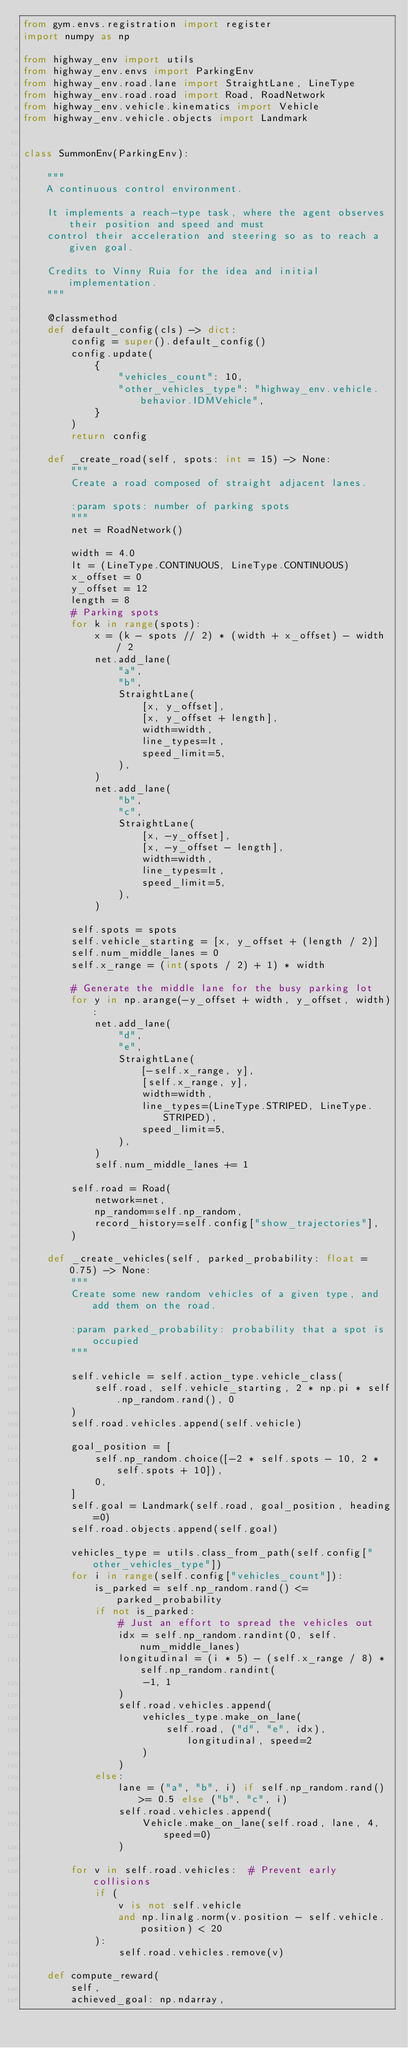Convert code to text. <code><loc_0><loc_0><loc_500><loc_500><_Python_>from gym.envs.registration import register
import numpy as np

from highway_env import utils
from highway_env.envs import ParkingEnv
from highway_env.road.lane import StraightLane, LineType
from highway_env.road.road import Road, RoadNetwork
from highway_env.vehicle.kinematics import Vehicle
from highway_env.vehicle.objects import Landmark


class SummonEnv(ParkingEnv):

    """
    A continuous control environment.

    It implements a reach-type task, where the agent observes their position and speed and must
    control their acceleration and steering so as to reach a given goal.

    Credits to Vinny Ruia for the idea and initial implementation.
    """

    @classmethod
    def default_config(cls) -> dict:
        config = super().default_config()
        config.update(
            {
                "vehicles_count": 10,
                "other_vehicles_type": "highway_env.vehicle.behavior.IDMVehicle",
            }
        )
        return config

    def _create_road(self, spots: int = 15) -> None:
        """
        Create a road composed of straight adjacent lanes.

        :param spots: number of parking spots
        """
        net = RoadNetwork()

        width = 4.0
        lt = (LineType.CONTINUOUS, LineType.CONTINUOUS)
        x_offset = 0
        y_offset = 12
        length = 8
        # Parking spots
        for k in range(spots):
            x = (k - spots // 2) * (width + x_offset) - width / 2
            net.add_lane(
                "a",
                "b",
                StraightLane(
                    [x, y_offset],
                    [x, y_offset + length],
                    width=width,
                    line_types=lt,
                    speed_limit=5,
                ),
            )
            net.add_lane(
                "b",
                "c",
                StraightLane(
                    [x, -y_offset],
                    [x, -y_offset - length],
                    width=width,
                    line_types=lt,
                    speed_limit=5,
                ),
            )

        self.spots = spots
        self.vehicle_starting = [x, y_offset + (length / 2)]
        self.num_middle_lanes = 0
        self.x_range = (int(spots / 2) + 1) * width

        # Generate the middle lane for the busy parking lot
        for y in np.arange(-y_offset + width, y_offset, width):
            net.add_lane(
                "d",
                "e",
                StraightLane(
                    [-self.x_range, y],
                    [self.x_range, y],
                    width=width,
                    line_types=(LineType.STRIPED, LineType.STRIPED),
                    speed_limit=5,
                ),
            )
            self.num_middle_lanes += 1

        self.road = Road(
            network=net,
            np_random=self.np_random,
            record_history=self.config["show_trajectories"],
        )

    def _create_vehicles(self, parked_probability: float = 0.75) -> None:
        """
        Create some new random vehicles of a given type, and add them on the road.

        :param parked_probability: probability that a spot is occupied
        """

        self.vehicle = self.action_type.vehicle_class(
            self.road, self.vehicle_starting, 2 * np.pi * self.np_random.rand(), 0
        )
        self.road.vehicles.append(self.vehicle)

        goal_position = [
            self.np_random.choice([-2 * self.spots - 10, 2 * self.spots + 10]),
            0,
        ]
        self.goal = Landmark(self.road, goal_position, heading=0)
        self.road.objects.append(self.goal)

        vehicles_type = utils.class_from_path(self.config["other_vehicles_type"])
        for i in range(self.config["vehicles_count"]):
            is_parked = self.np_random.rand() <= parked_probability
            if not is_parked:
                # Just an effort to spread the vehicles out
                idx = self.np_random.randint(0, self.num_middle_lanes)
                longitudinal = (i * 5) - (self.x_range / 8) * self.np_random.randint(
                    -1, 1
                )
                self.road.vehicles.append(
                    vehicles_type.make_on_lane(
                        self.road, ("d", "e", idx), longitudinal, speed=2
                    )
                )
            else:
                lane = ("a", "b", i) if self.np_random.rand() >= 0.5 else ("b", "c", i)
                self.road.vehicles.append(
                    Vehicle.make_on_lane(self.road, lane, 4, speed=0)
                )

        for v in self.road.vehicles:  # Prevent early collisions
            if (
                v is not self.vehicle
                and np.linalg.norm(v.position - self.vehicle.position) < 20
            ):
                self.road.vehicles.remove(v)

    def compute_reward(
        self,
        achieved_goal: np.ndarray,</code> 